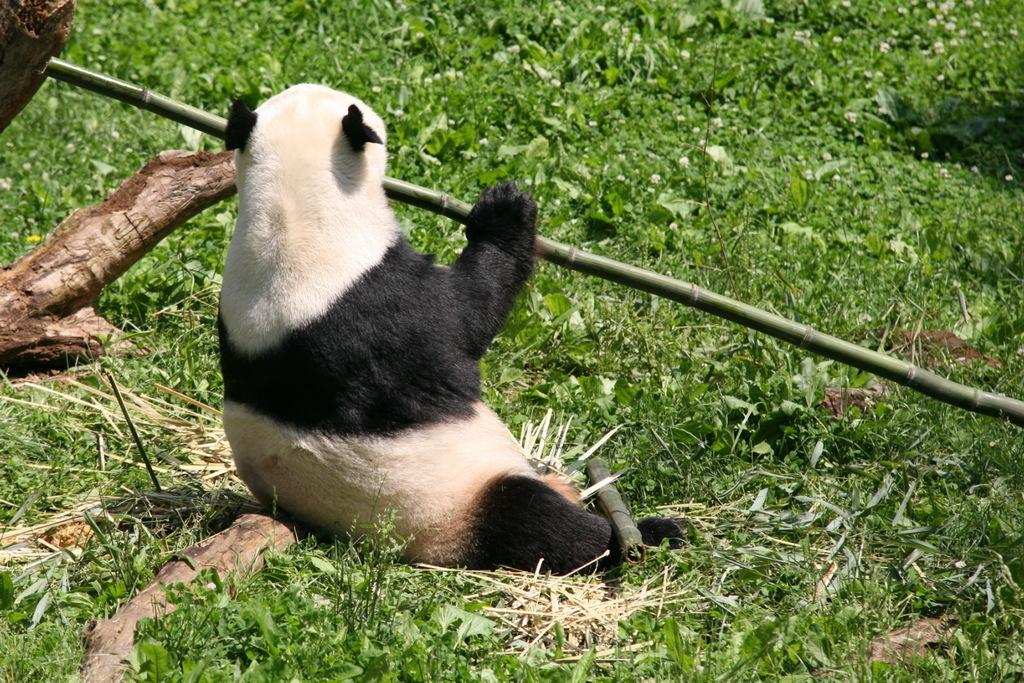What animal is in the center of the image? There is a panda in the center of the image. What is the panda holding in its hand? The panda is holding a bamboo stick. What type of vegetation can be seen at the bottom of the image? There is grass at the bottom of the image. What material is visible to the left side of the image? There is tree bark visible to the left side of the image. Where is the sofa located in the image? There is no sofa present in the image. What type of snails can be seen crawling on the tree bark in the image? There are no snails visible in the image; only the panda, bamboo stick, grass, and tree bark are present. 